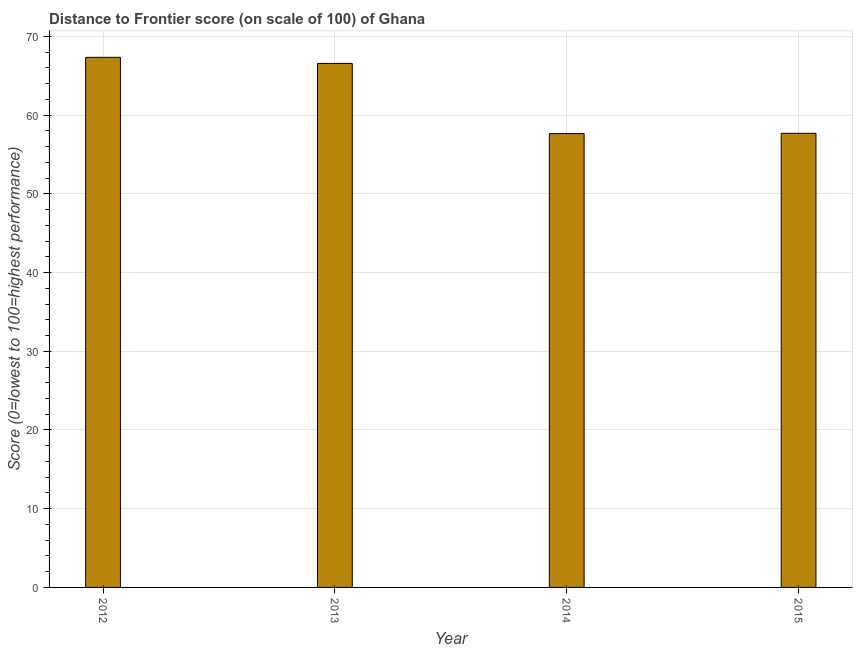Does the graph contain grids?
Offer a terse response. Yes. What is the title of the graph?
Offer a very short reply. Distance to Frontier score (on scale of 100) of Ghana. What is the label or title of the X-axis?
Give a very brief answer. Year. What is the label or title of the Y-axis?
Your answer should be very brief. Score (0=lowest to 100=highest performance). What is the distance to frontier score in 2014?
Your response must be concise. 57.65. Across all years, what is the maximum distance to frontier score?
Provide a short and direct response. 67.34. Across all years, what is the minimum distance to frontier score?
Give a very brief answer. 57.65. In which year was the distance to frontier score maximum?
Give a very brief answer. 2012. In which year was the distance to frontier score minimum?
Provide a succinct answer. 2014. What is the sum of the distance to frontier score?
Offer a very short reply. 249.25. What is the difference between the distance to frontier score in 2012 and 2015?
Offer a very short reply. 9.65. What is the average distance to frontier score per year?
Keep it short and to the point. 62.31. What is the median distance to frontier score?
Ensure brevity in your answer.  62.13. Do a majority of the years between 2014 and 2012 (inclusive) have distance to frontier score greater than 24 ?
Provide a succinct answer. Yes. What is the ratio of the distance to frontier score in 2012 to that in 2015?
Your answer should be very brief. 1.17. Is the distance to frontier score in 2012 less than that in 2013?
Make the answer very short. No. Is the difference between the distance to frontier score in 2014 and 2015 greater than the difference between any two years?
Offer a terse response. No. What is the difference between the highest and the second highest distance to frontier score?
Your answer should be compact. 0.77. Is the sum of the distance to frontier score in 2012 and 2015 greater than the maximum distance to frontier score across all years?
Provide a succinct answer. Yes. What is the difference between the highest and the lowest distance to frontier score?
Ensure brevity in your answer.  9.69. In how many years, is the distance to frontier score greater than the average distance to frontier score taken over all years?
Offer a very short reply. 2. Are the values on the major ticks of Y-axis written in scientific E-notation?
Provide a short and direct response. No. What is the Score (0=lowest to 100=highest performance) in 2012?
Offer a terse response. 67.34. What is the Score (0=lowest to 100=highest performance) of 2013?
Your response must be concise. 66.57. What is the Score (0=lowest to 100=highest performance) in 2014?
Make the answer very short. 57.65. What is the Score (0=lowest to 100=highest performance) in 2015?
Offer a very short reply. 57.69. What is the difference between the Score (0=lowest to 100=highest performance) in 2012 and 2013?
Ensure brevity in your answer.  0.77. What is the difference between the Score (0=lowest to 100=highest performance) in 2012 and 2014?
Your answer should be compact. 9.69. What is the difference between the Score (0=lowest to 100=highest performance) in 2012 and 2015?
Give a very brief answer. 9.65. What is the difference between the Score (0=lowest to 100=highest performance) in 2013 and 2014?
Ensure brevity in your answer.  8.92. What is the difference between the Score (0=lowest to 100=highest performance) in 2013 and 2015?
Ensure brevity in your answer.  8.88. What is the difference between the Score (0=lowest to 100=highest performance) in 2014 and 2015?
Ensure brevity in your answer.  -0.04. What is the ratio of the Score (0=lowest to 100=highest performance) in 2012 to that in 2013?
Your response must be concise. 1.01. What is the ratio of the Score (0=lowest to 100=highest performance) in 2012 to that in 2014?
Make the answer very short. 1.17. What is the ratio of the Score (0=lowest to 100=highest performance) in 2012 to that in 2015?
Ensure brevity in your answer.  1.17. What is the ratio of the Score (0=lowest to 100=highest performance) in 2013 to that in 2014?
Make the answer very short. 1.16. What is the ratio of the Score (0=lowest to 100=highest performance) in 2013 to that in 2015?
Give a very brief answer. 1.15. What is the ratio of the Score (0=lowest to 100=highest performance) in 2014 to that in 2015?
Your response must be concise. 1. 